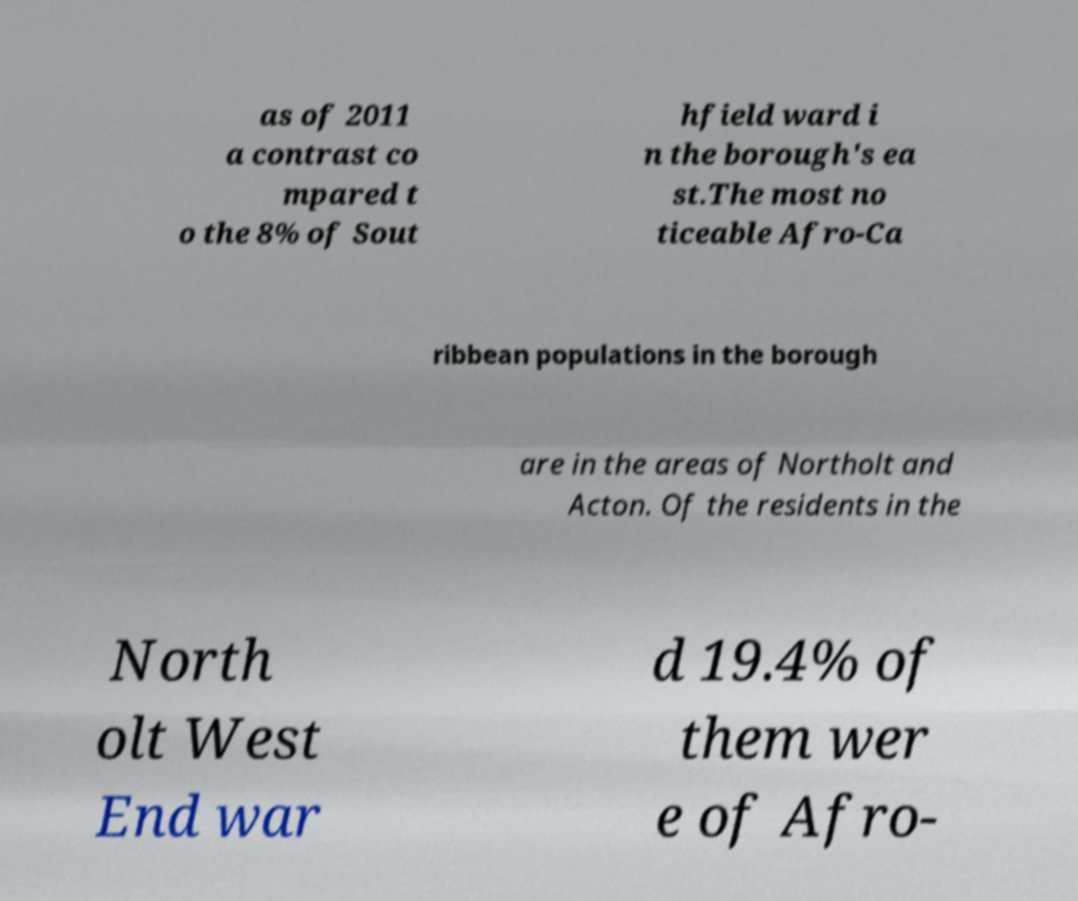Can you accurately transcribe the text from the provided image for me? as of 2011 a contrast co mpared t o the 8% of Sout hfield ward i n the borough's ea st.The most no ticeable Afro-Ca ribbean populations in the borough are in the areas of Northolt and Acton. Of the residents in the North olt West End war d 19.4% of them wer e of Afro- 